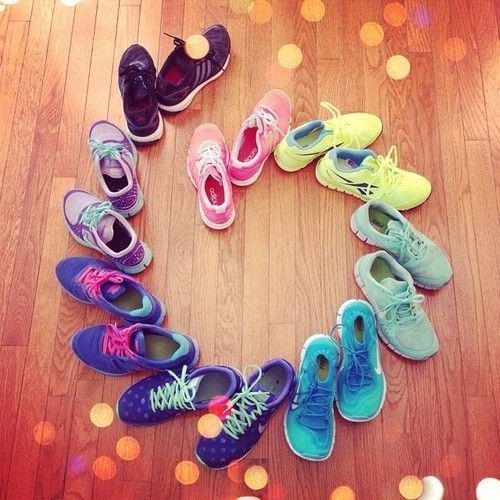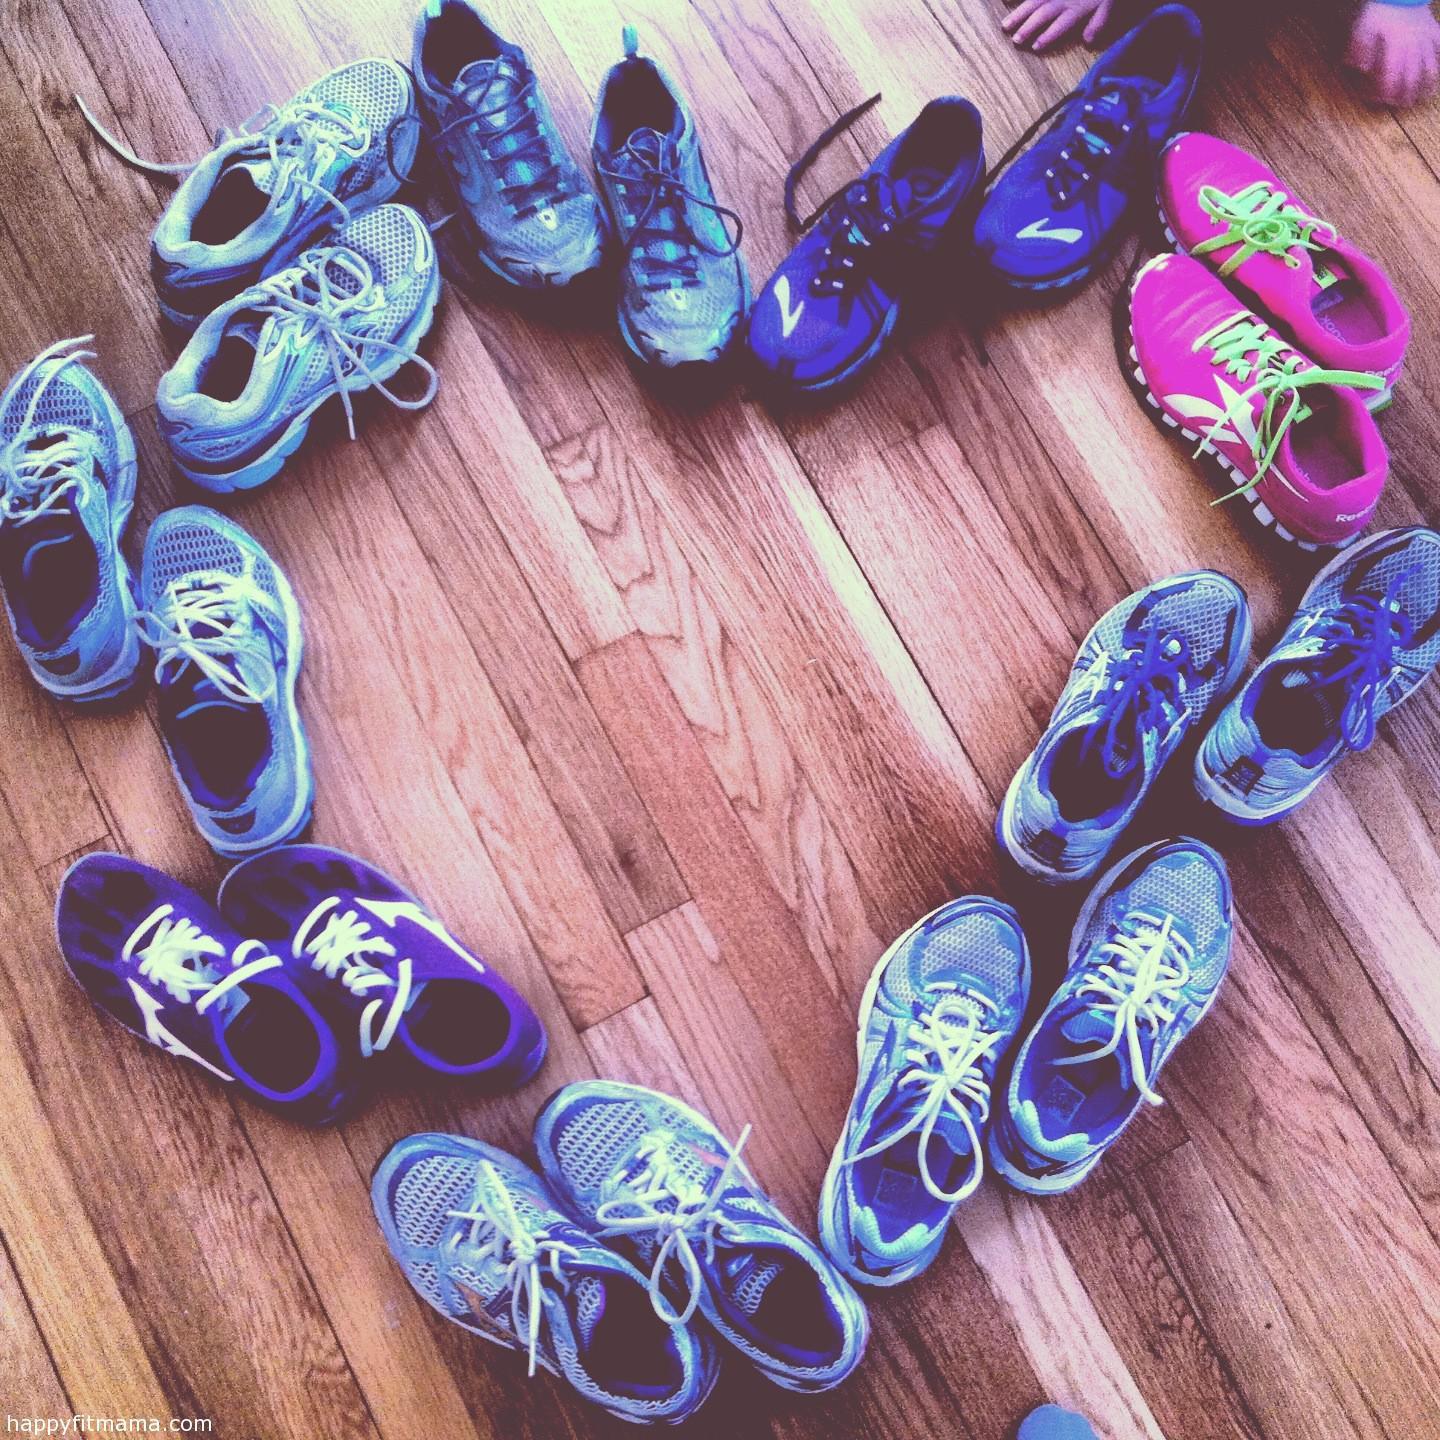The first image is the image on the left, the second image is the image on the right. Evaluate the accuracy of this statement regarding the images: "One image contains at least 6 pairs of shoes.". Is it true? Answer yes or no. Yes. The first image is the image on the left, the second image is the image on the right. Evaluate the accuracy of this statement regarding the images: "Each image includes exactly one pair of sneakers.". Is it true? Answer yes or no. No. 